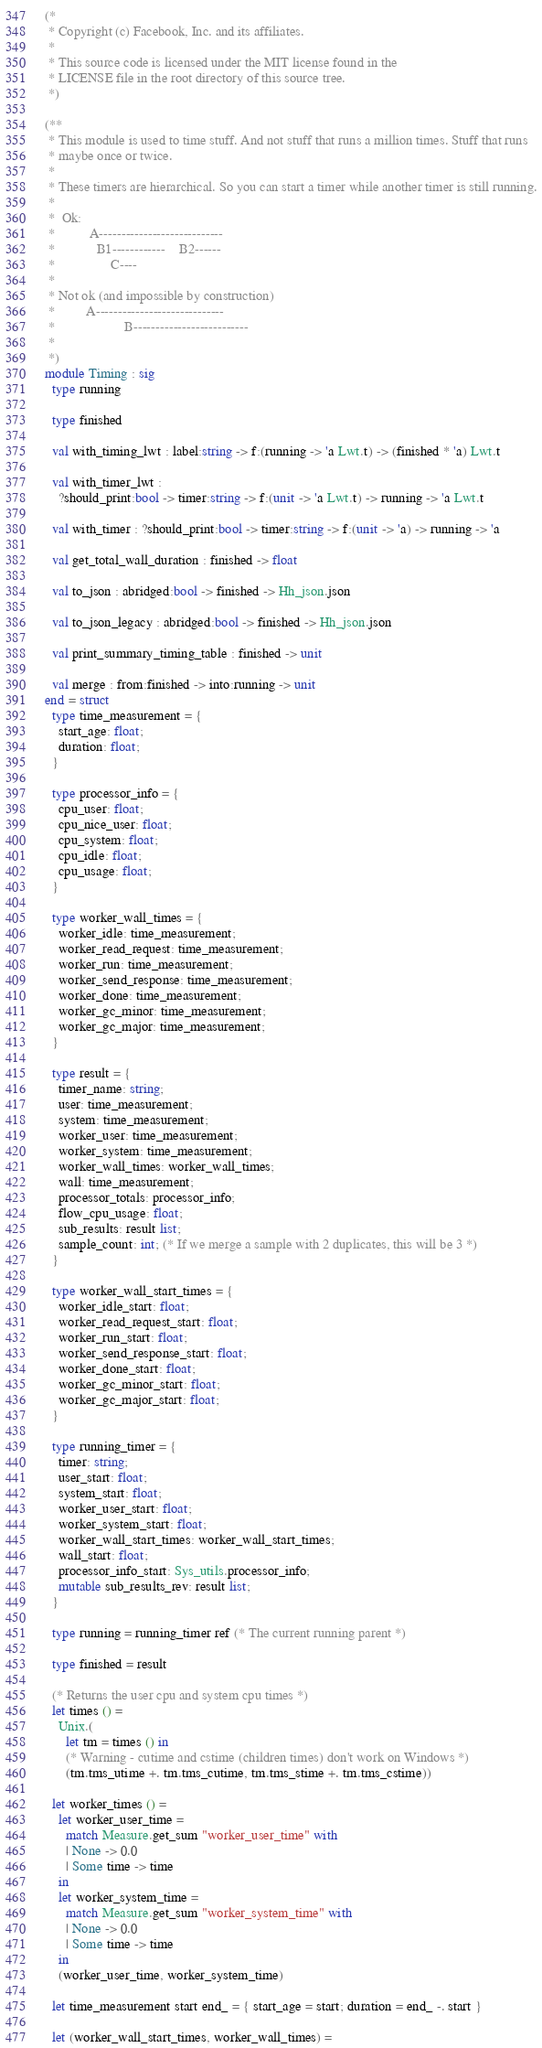Convert code to text. <code><loc_0><loc_0><loc_500><loc_500><_OCaml_>(*
 * Copyright (c) Facebook, Inc. and its affiliates.
 *
 * This source code is licensed under the MIT license found in the
 * LICENSE file in the root directory of this source tree.
 *)

(**
 * This module is used to time stuff. And not stuff that runs a million times. Stuff that runs
 * maybe once or twice.
 *
 * These timers are hierarchical. So you can start a timer while another timer is still running.
 *
 *  Ok:
 *          A----------------------------
 *            B1------------    B2------
 *                C----
 *
 * Not ok (and impossible by construction)
 *         A-----------------------------
 *                    B--------------------------
 *
 *)
module Timing : sig
  type running

  type finished

  val with_timing_lwt : label:string -> f:(running -> 'a Lwt.t) -> (finished * 'a) Lwt.t

  val with_timer_lwt :
    ?should_print:bool -> timer:string -> f:(unit -> 'a Lwt.t) -> running -> 'a Lwt.t

  val with_timer : ?should_print:bool -> timer:string -> f:(unit -> 'a) -> running -> 'a

  val get_total_wall_duration : finished -> float

  val to_json : abridged:bool -> finished -> Hh_json.json

  val to_json_legacy : abridged:bool -> finished -> Hh_json.json

  val print_summary_timing_table : finished -> unit

  val merge : from:finished -> into:running -> unit
end = struct
  type time_measurement = {
    start_age: float;
    duration: float;
  }

  type processor_info = {
    cpu_user: float;
    cpu_nice_user: float;
    cpu_system: float;
    cpu_idle: float;
    cpu_usage: float;
  }

  type worker_wall_times = {
    worker_idle: time_measurement;
    worker_read_request: time_measurement;
    worker_run: time_measurement;
    worker_send_response: time_measurement;
    worker_done: time_measurement;
    worker_gc_minor: time_measurement;
    worker_gc_major: time_measurement;
  }

  type result = {
    timer_name: string;
    user: time_measurement;
    system: time_measurement;
    worker_user: time_measurement;
    worker_system: time_measurement;
    worker_wall_times: worker_wall_times;
    wall: time_measurement;
    processor_totals: processor_info;
    flow_cpu_usage: float;
    sub_results: result list;
    sample_count: int; (* If we merge a sample with 2 duplicates, this will be 3 *)
  }

  type worker_wall_start_times = {
    worker_idle_start: float;
    worker_read_request_start: float;
    worker_run_start: float;
    worker_send_response_start: float;
    worker_done_start: float;
    worker_gc_minor_start: float;
    worker_gc_major_start: float;
  }

  type running_timer = {
    timer: string;
    user_start: float;
    system_start: float;
    worker_user_start: float;
    worker_system_start: float;
    worker_wall_start_times: worker_wall_start_times;
    wall_start: float;
    processor_info_start: Sys_utils.processor_info;
    mutable sub_results_rev: result list;
  }

  type running = running_timer ref (* The current running parent *)

  type finished = result

  (* Returns the user cpu and system cpu times *)
  let times () =
    Unix.(
      let tm = times () in
      (* Warning - cutime and cstime (children times) don't work on Windows *)
      (tm.tms_utime +. tm.tms_cutime, tm.tms_stime +. tm.tms_cstime))

  let worker_times () =
    let worker_user_time =
      match Measure.get_sum "worker_user_time" with
      | None -> 0.0
      | Some time -> time
    in
    let worker_system_time =
      match Measure.get_sum "worker_system_time" with
      | None -> 0.0
      | Some time -> time
    in
    (worker_user_time, worker_system_time)

  let time_measurement start end_ = { start_age = start; duration = end_ -. start }

  let (worker_wall_start_times, worker_wall_times) =</code> 